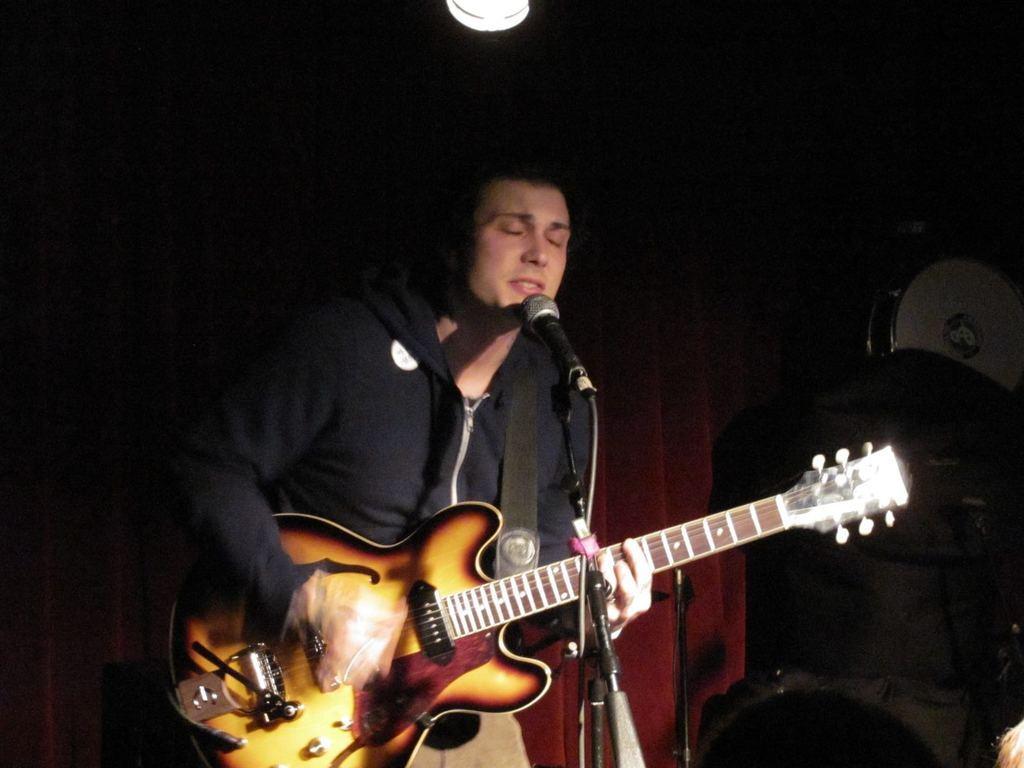How would you summarize this image in a sentence or two? In this image I see a man who is standing in front of a mic and he is holding a guitar. In the background I see the light and other things over here. 